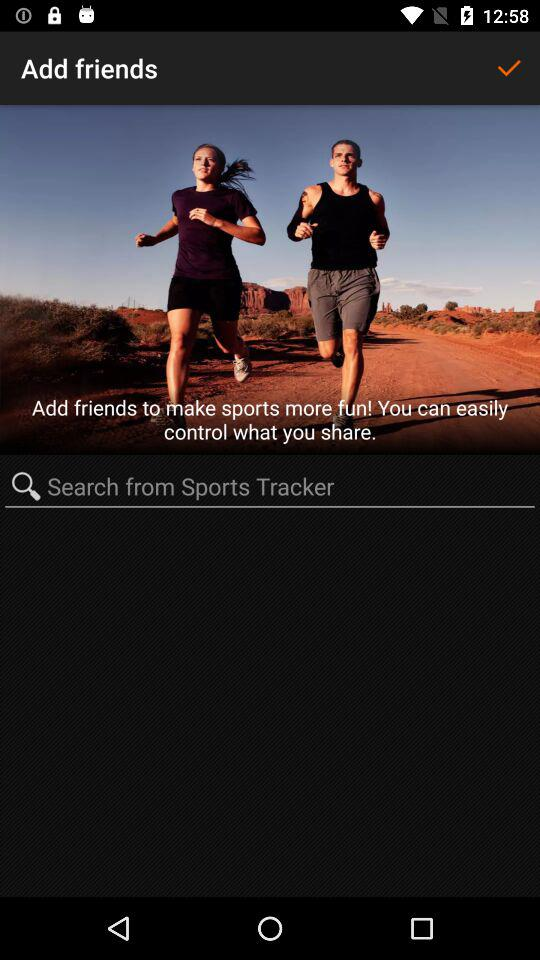Where do we have to search from? You have to search from "Sports Tracker". 